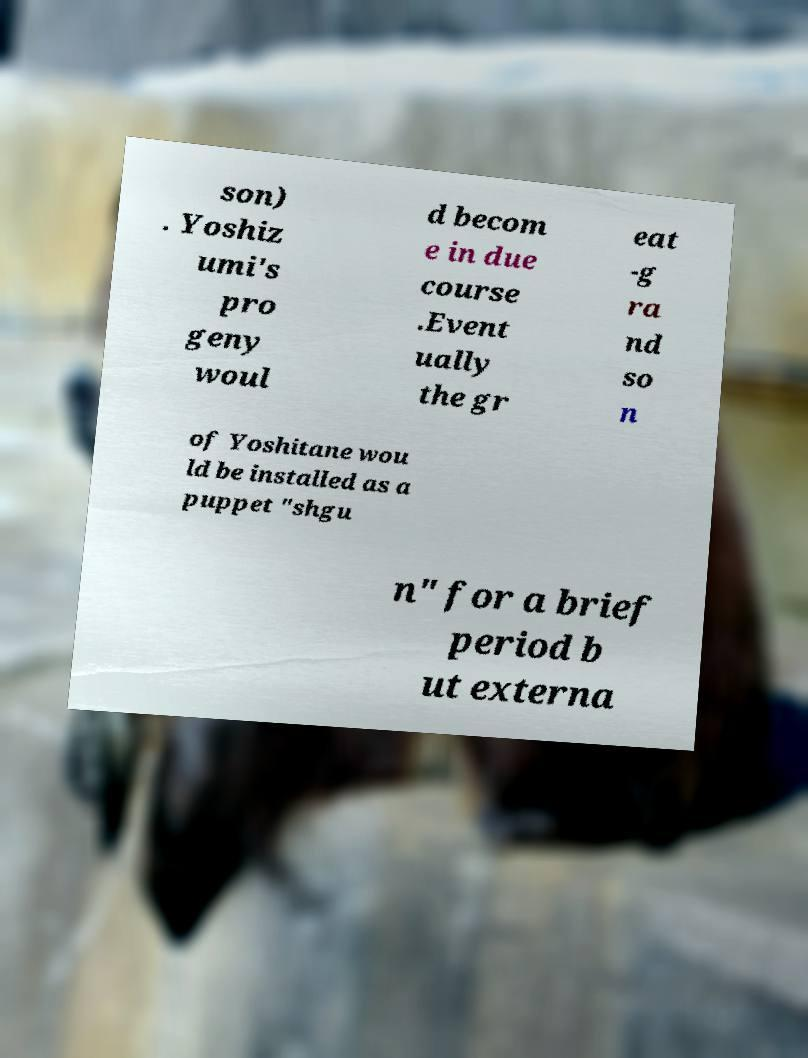For documentation purposes, I need the text within this image transcribed. Could you provide that? son) . Yoshiz umi's pro geny woul d becom e in due course .Event ually the gr eat -g ra nd so n of Yoshitane wou ld be installed as a puppet "shgu n" for a brief period b ut externa 